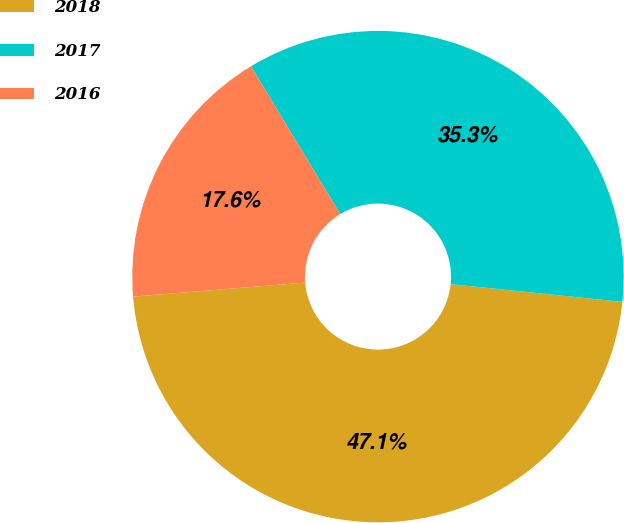Convert chart. <chart><loc_0><loc_0><loc_500><loc_500><pie_chart><fcel>2018<fcel>2017<fcel>2016<nl><fcel>47.06%<fcel>35.29%<fcel>17.65%<nl></chart> 